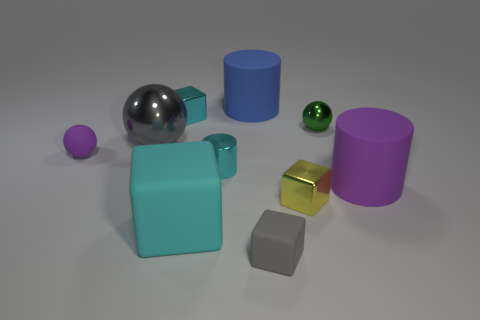Is the color of the metallic cylinder the same as the big block?
Keep it short and to the point. Yes. How many purple objects are the same shape as the tiny yellow thing?
Offer a very short reply. 0. Is the big cyan object the same shape as the large metal object?
Offer a very short reply. No. What number of things are either small things that are to the right of the tiny cyan shiny cube or tiny yellow shiny objects?
Keep it short and to the point. 4. There is a purple matte thing to the left of the metal cube to the left of the tiny cyan thing that is in front of the small green ball; what is its shape?
Your response must be concise. Sphere. What shape is the tiny purple object that is made of the same material as the gray block?
Offer a very short reply. Sphere. How big is the cyan matte thing?
Offer a terse response. Large. Do the cyan metal block and the green shiny thing have the same size?
Make the answer very short. Yes. What number of things are either matte things in front of the large gray metallic object or cyan matte blocks right of the big gray thing?
Your response must be concise. 4. How many rubber objects are right of the metallic block behind the large matte cylinder that is in front of the large metallic ball?
Offer a very short reply. 4. 